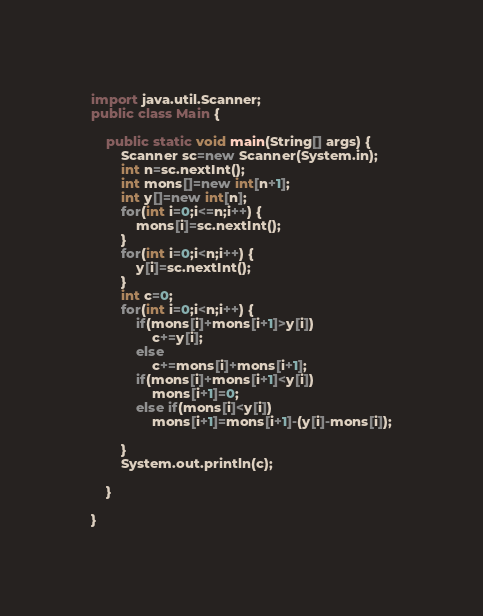<code> <loc_0><loc_0><loc_500><loc_500><_Java_>import java.util.Scanner;
public class Main {

	public static void main(String[] args) {
		Scanner sc=new Scanner(System.in);
		int n=sc.nextInt();
		int mons[]=new int[n+1];
		int y[]=new int[n];
		for(int i=0;i<=n;i++) {
			mons[i]=sc.nextInt();
		}
		for(int i=0;i<n;i++) {
			y[i]=sc.nextInt();
		}
		int c=0;
		for(int i=0;i<n;i++) {
			if(mons[i]+mons[i+1]>y[i])
			    c+=y[i];
			else
				c+=mons[i]+mons[i+1];
			if(mons[i]+mons[i+1]<y[i])
				mons[i+1]=0;
			else if(mons[i]<y[i])
				mons[i+1]=mons[i+1]-(y[i]-mons[i]);

		}
		System.out.println(c);

	}

}
</code> 